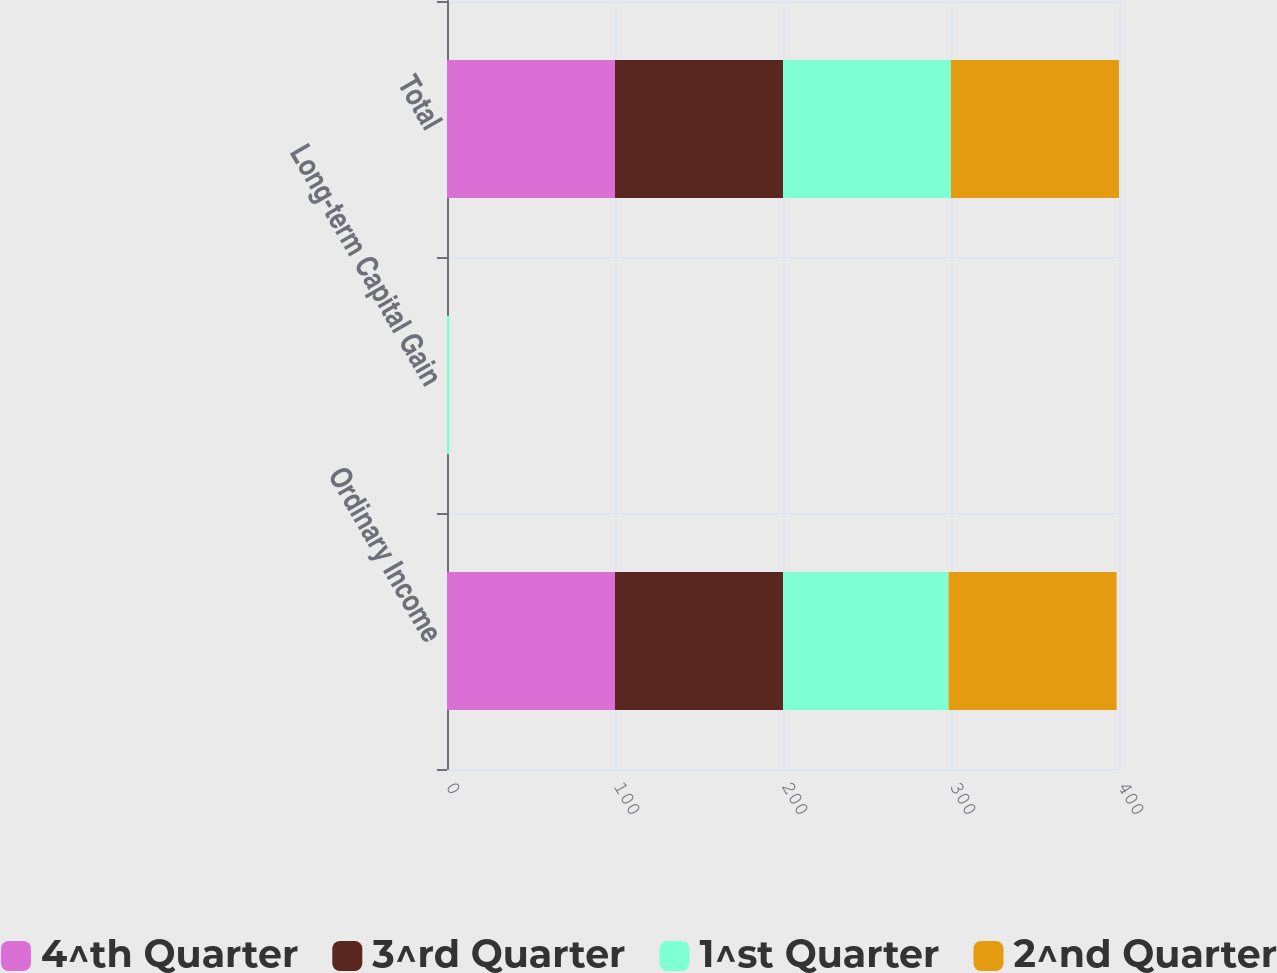<chart> <loc_0><loc_0><loc_500><loc_500><stacked_bar_chart><ecel><fcel>Ordinary Income<fcel>Long-term Capital Gain<fcel>Total<nl><fcel>4^th Quarter<fcel>100<fcel>0<fcel>100<nl><fcel>3^rd Quarter<fcel>100<fcel>0<fcel>100<nl><fcel>1^st Quarter<fcel>98.57<fcel>1.43<fcel>100<nl><fcel>2^nd Quarter<fcel>100<fcel>0<fcel>100<nl></chart> 